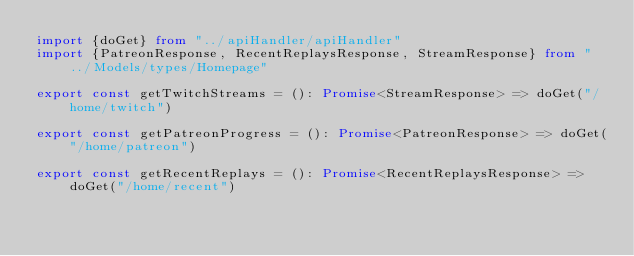Convert code to text. <code><loc_0><loc_0><loc_500><loc_500><_TypeScript_>import {doGet} from "../apiHandler/apiHandler"
import {PatreonResponse, RecentReplaysResponse, StreamResponse} from "../Models/types/Homepage"

export const getTwitchStreams = (): Promise<StreamResponse> => doGet("/home/twitch")

export const getPatreonProgress = (): Promise<PatreonResponse> => doGet("/home/patreon")

export const getRecentReplays = (): Promise<RecentReplaysResponse> => doGet("/home/recent")
</code> 